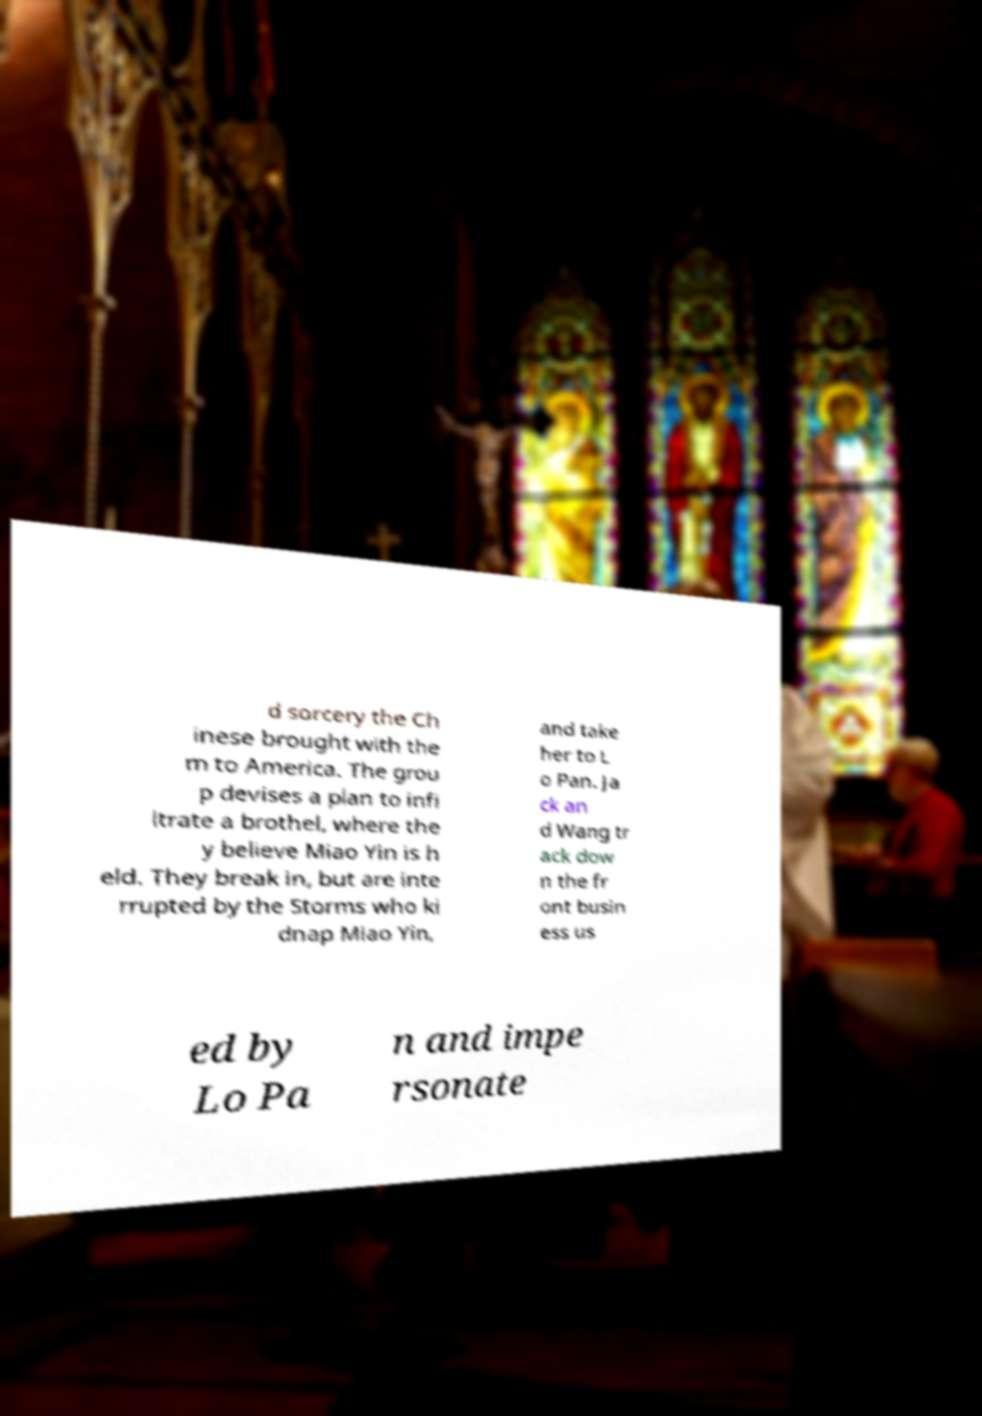For documentation purposes, I need the text within this image transcribed. Could you provide that? d sorcery the Ch inese brought with the m to America. The grou p devises a plan to infi ltrate a brothel, where the y believe Miao Yin is h eld. They break in, but are inte rrupted by the Storms who ki dnap Miao Yin, and take her to L o Pan. Ja ck an d Wang tr ack dow n the fr ont busin ess us ed by Lo Pa n and impe rsonate 